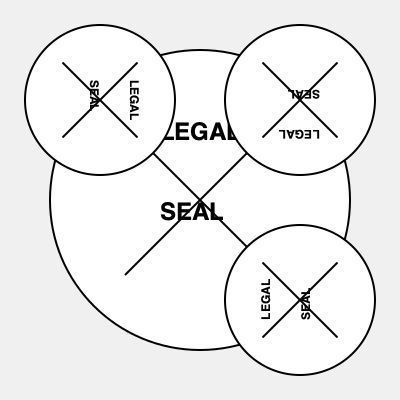Which of the smaller seals (A, B, or C) is oriented correctly in relation to the large central seal? To determine the correct orientation of the legal document seal, follow these steps:

1. Observe the large central seal as the reference point. This seal is in the correct orientation with "LEGAL" at the top and "SEAL" at the bottom.

2. Examine each of the smaller seals (A, B, and C) in clockwise order:
   A: Top-left (rotated 90 degrees clockwise)
   B: Top-right (rotated 180 degrees)
   C: Bottom-right (rotated 270 degrees clockwise or 90 degrees counterclockwise)

3. Compare the orientation of the text and the "X" pattern in each smaller seal to the central seal:
   A: "LEGAL" is on the right, "SEAL" on the left - incorrect
   B: "LEGAL" is at the bottom, "SEAL" at the top - incorrect
   C: "LEGAL" is at the top, "SEAL" at the bottom - correct

4. Identify that seal C (bottom-right) matches the orientation of the central seal, with "LEGAL" at the top and "SEAL" at the bottom.
Answer: C 